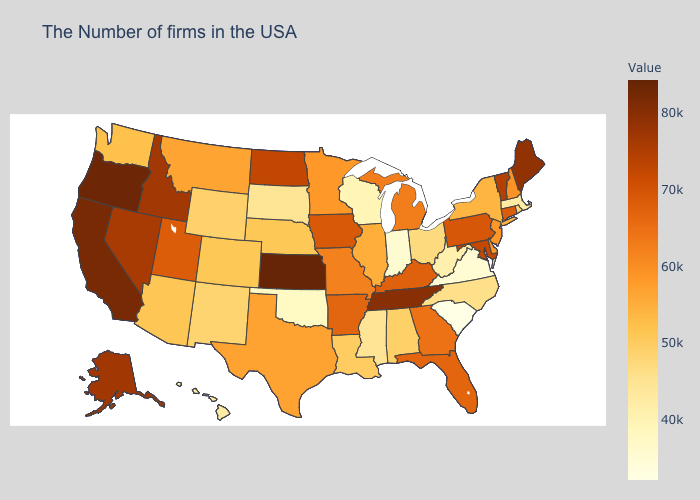Does Arizona have a lower value than Wisconsin?
Concise answer only. No. Which states have the lowest value in the USA?
Quick response, please. South Carolina. Among the states that border West Virginia , which have the lowest value?
Answer briefly. Virginia. Does Kansas have the highest value in the USA?
Keep it brief. Yes. Which states have the highest value in the USA?
Give a very brief answer. Kansas. Which states hav the highest value in the South?
Be succinct. Tennessee. 